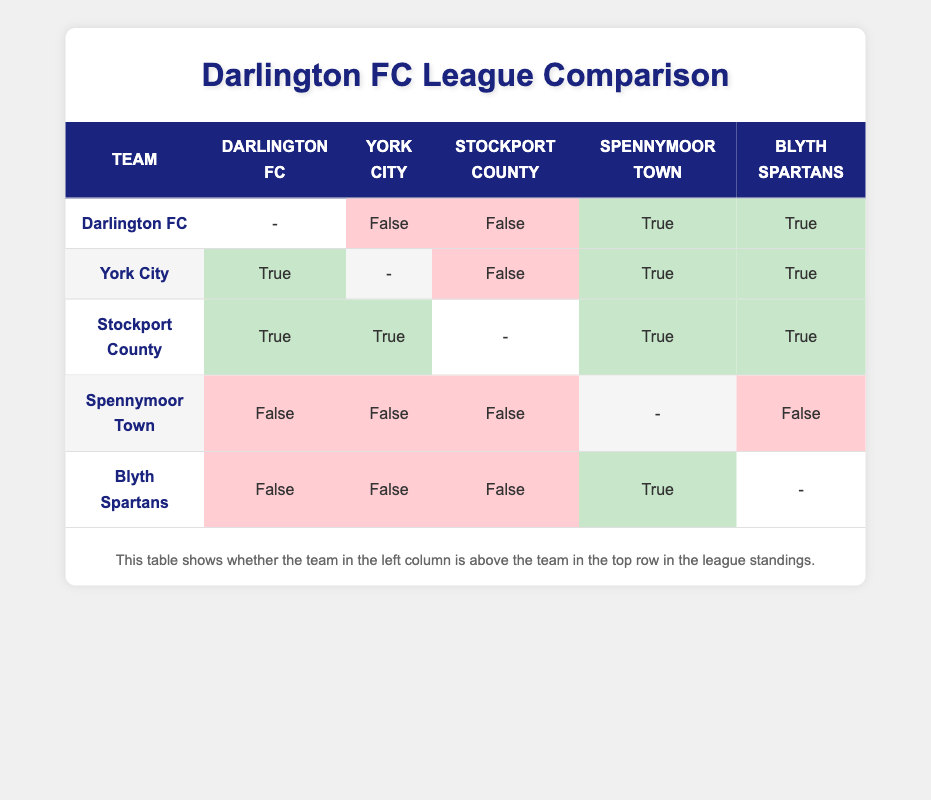What team has the highest points? Stockport County has 62 points, which is the highest in the table.
Answer: Stockport County Is Darlington FC above Blyth Spartans? According to the table, Darlington FC is above Blyth Spartans, as indicated by "True" in the corresponding cell.
Answer: Yes How many points does York City have compared to Spennymoor Town? York City has 60 points, while Spennymoor Town has 50 points. York City's points are 10 more than Spennymoor Town's.
Answer: 10 more Which teams is Darlington FC above in the standings? Darlington FC is above Spennymoor Town and Blyth Spartans, as indicated by "True" in their respective columns.
Answer: Spennymoor Town, Blyth Spartans Can you name the teams that are above Darlington FC? York City and Stockport County are above Darlington FC, as shown by "True" in their respective columns.
Answer: York City, Stockport County What is the goal difference for Stockport County? Stockport County has a goal difference of 24 (55 goals for minus 31 goals against).
Answer: 24 Is it true that Spennymoor Town is above Darlington FC? The table indicates "False" for the comparison between Spennymoor Town and Darlington FC, showing that Spennymoor Town is not above Darlington FC.
Answer: No What is the combined total of wins for both Darlington FC and Blyth Spartans? Darlington FC has 16 wins and Blyth Spartans have 15; therefore, 16 + 15 equals 31 wins in total.
Answer: 31 Which team has the highest goal difference, and what is that value? Stockport County has the highest goal difference, which is 24, as seen in the goal difference column.
Answer: 24 